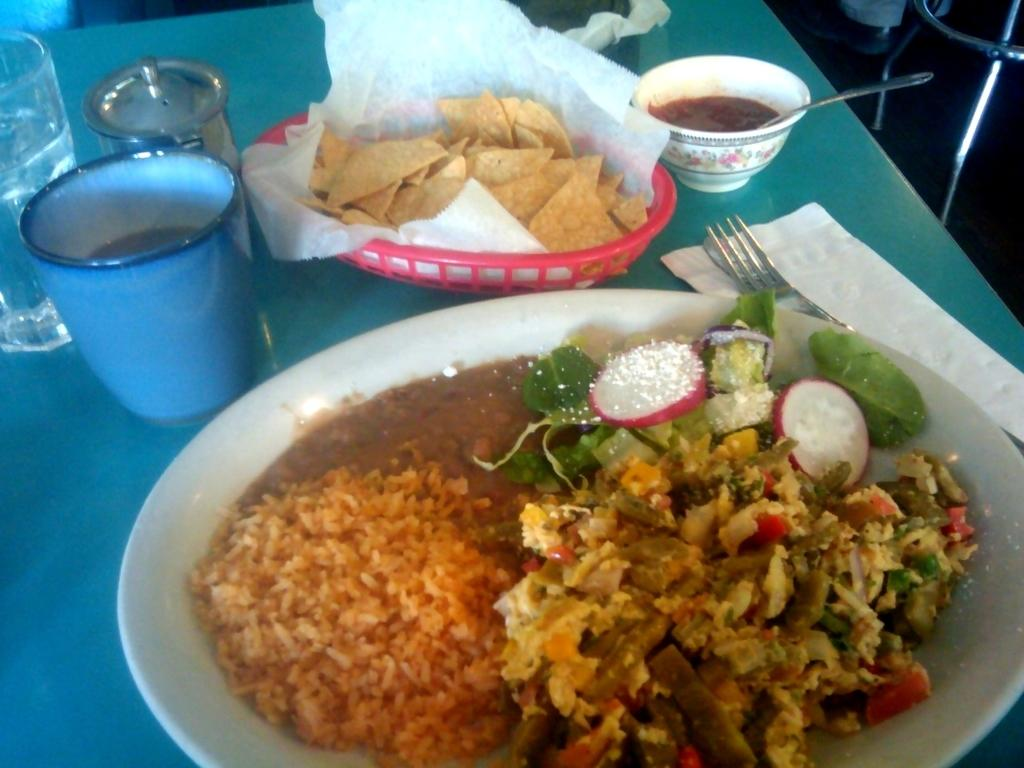What piece of furniture is present in the image? There is a table in the image. What is placed on the table? There is a plate on the table, and there is food on the plate. What else can be seen on the table? There are glasses, tissue paper, and a fork on the table. What type of pear can be seen laughing near the stove in the image? There is no pear or stove present in the image. 